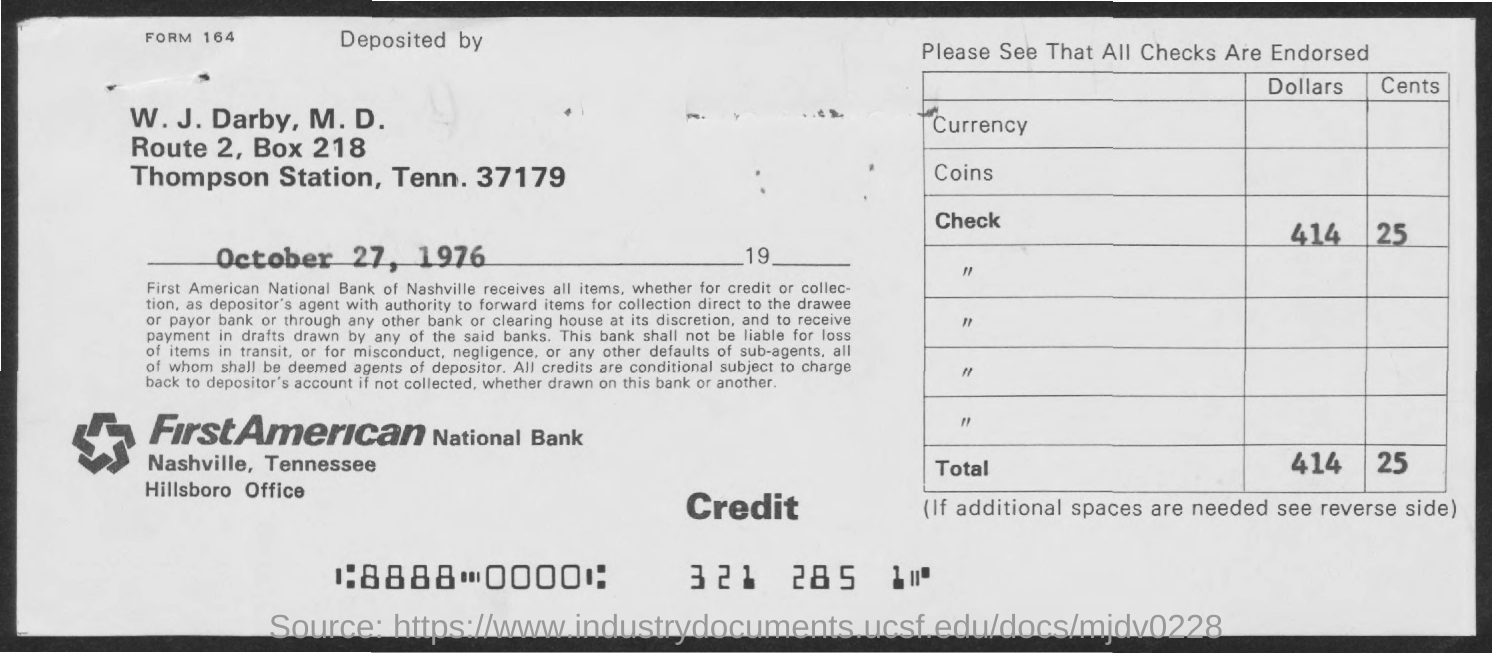What is the Bank Name ?
Your answer should be very brief. FirstAmerican National Bank. What is the BOX Number ?
Give a very brief answer. 218. When is the memorandum dated on ?
Offer a terse response. October 27, 1976. 